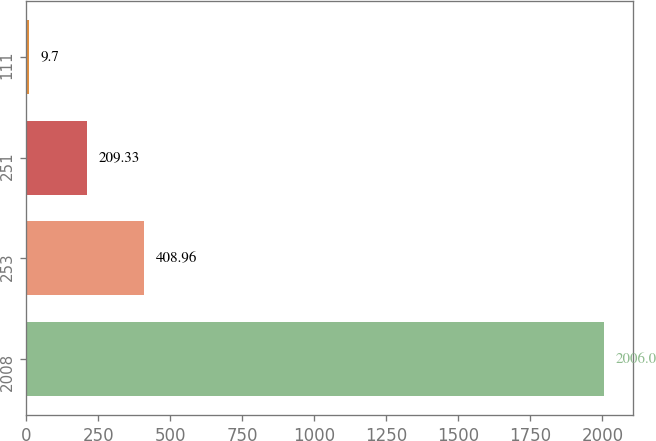Convert chart. <chart><loc_0><loc_0><loc_500><loc_500><bar_chart><fcel>2008<fcel>253<fcel>251<fcel>111<nl><fcel>2006<fcel>408.96<fcel>209.33<fcel>9.7<nl></chart> 